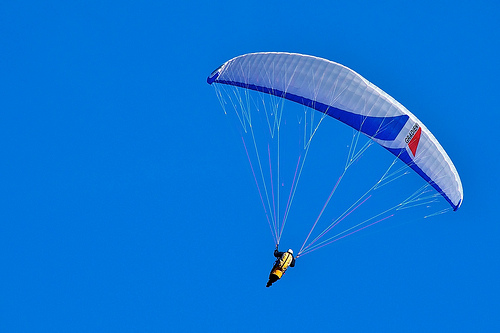What unique geographical feature can you see? In the image, the main geographical feature is the clear and expansive sky, which serves as a vast, unobstructed canvas. This open skyscape provides the perfect environment for paragliding, offering both challenges and beauty to those who dare to fly. 